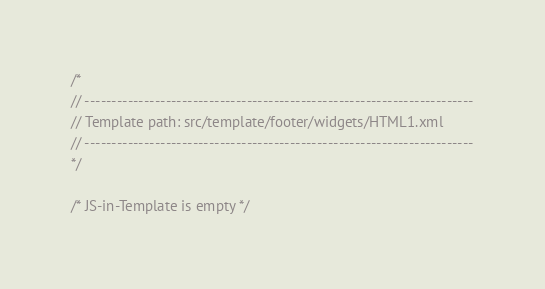<code> <loc_0><loc_0><loc_500><loc_500><_JavaScript_>/*
// ------------------------------------------------------------------------
// Template path: src/template/footer/widgets/HTML1.xml
// ------------------------------------------------------------------------
*/

/* JS-in-Template is empty */
</code> 